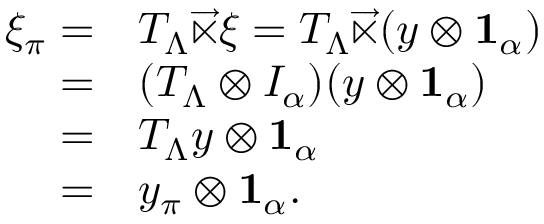Convert formula to latex. <formula><loc_0><loc_0><loc_500><loc_500>\begin{array} { r l } { \xi _ { \pi } = } & { T _ { \Lambda } \overrightarrow { \ltimes } \xi = T _ { \Lambda } \overrightarrow { \ltimes } ( y \otimes 1 _ { \alpha } ) } \\ { = } & { ( T _ { \Lambda } \otimes I _ { \alpha } ) ( y \otimes 1 _ { \alpha } ) } \\ { = } & { T _ { \Lambda } y \otimes 1 _ { \alpha } } \\ { = } & { y _ { \pi } \otimes 1 _ { \alpha } . } \end{array}</formula> 